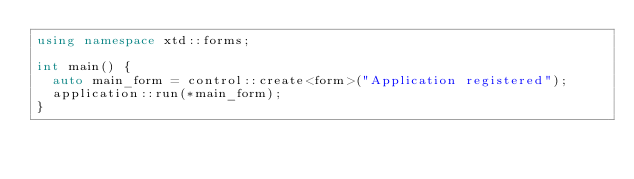Convert code to text. <code><loc_0><loc_0><loc_500><loc_500><_C++_>using namespace xtd::forms;

int main() {
  auto main_form = control::create<form>("Application registered");
  application::run(*main_form);
}
</code> 